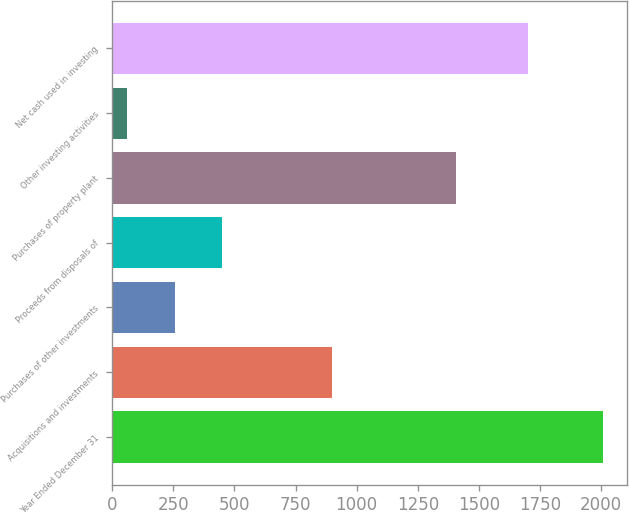<chart> <loc_0><loc_0><loc_500><loc_500><bar_chart><fcel>Year Ended December 31<fcel>Acquisitions and investments<fcel>Purchases of other investments<fcel>Proceeds from disposals of<fcel>Purchases of property plant<fcel>Other investing activities<fcel>Net cash used in investing<nl><fcel>2006<fcel>901<fcel>256.4<fcel>450.8<fcel>1407<fcel>62<fcel>1700<nl></chart> 